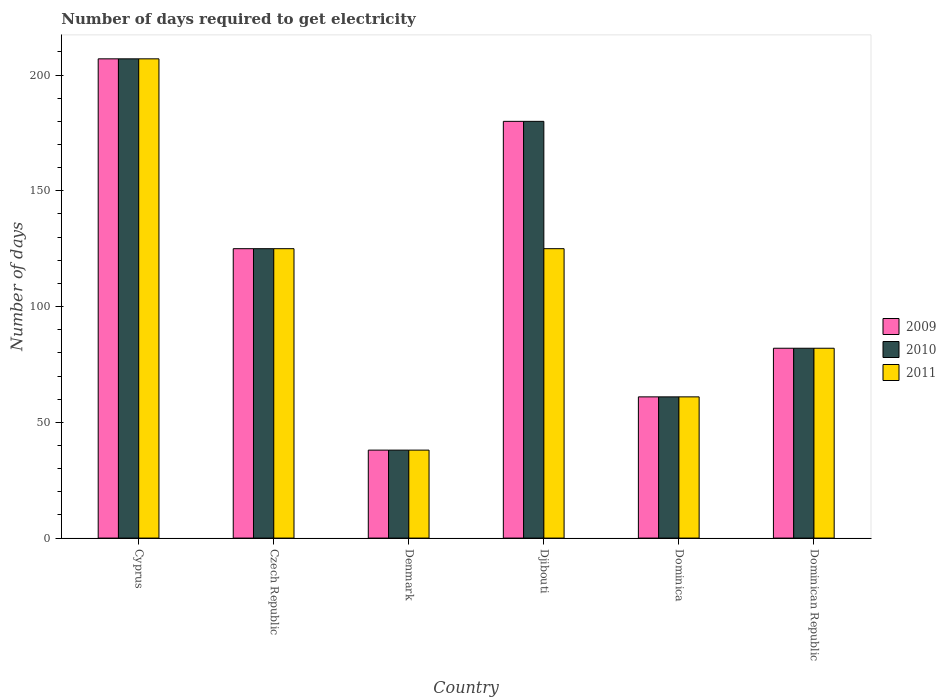How many different coloured bars are there?
Your response must be concise. 3. How many bars are there on the 2nd tick from the left?
Ensure brevity in your answer.  3. How many bars are there on the 4th tick from the right?
Keep it short and to the point. 3. What is the label of the 1st group of bars from the left?
Provide a succinct answer. Cyprus. What is the number of days required to get electricity in in 2011 in Czech Republic?
Keep it short and to the point. 125. Across all countries, what is the maximum number of days required to get electricity in in 2010?
Your response must be concise. 207. Across all countries, what is the minimum number of days required to get electricity in in 2011?
Your answer should be very brief. 38. In which country was the number of days required to get electricity in in 2010 maximum?
Your answer should be compact. Cyprus. In which country was the number of days required to get electricity in in 2010 minimum?
Offer a terse response. Denmark. What is the total number of days required to get electricity in in 2009 in the graph?
Your answer should be compact. 693. What is the difference between the number of days required to get electricity in in 2010 in Cyprus and the number of days required to get electricity in in 2011 in Dominican Republic?
Offer a terse response. 125. What is the average number of days required to get electricity in in 2011 per country?
Your answer should be compact. 106.33. What is the ratio of the number of days required to get electricity in in 2010 in Czech Republic to that in Dominica?
Offer a terse response. 2.05. Is the number of days required to get electricity in in 2010 in Czech Republic less than that in Dominican Republic?
Offer a terse response. No. What is the difference between the highest and the second highest number of days required to get electricity in in 2011?
Your response must be concise. -82. What is the difference between the highest and the lowest number of days required to get electricity in in 2009?
Keep it short and to the point. 169. In how many countries, is the number of days required to get electricity in in 2010 greater than the average number of days required to get electricity in in 2010 taken over all countries?
Your response must be concise. 3. What does the 2nd bar from the left in Denmark represents?
Provide a short and direct response. 2010. What does the 2nd bar from the right in Djibouti represents?
Your answer should be compact. 2010. How many bars are there?
Provide a succinct answer. 18. How many countries are there in the graph?
Offer a terse response. 6. What is the difference between two consecutive major ticks on the Y-axis?
Your answer should be very brief. 50. Does the graph contain grids?
Make the answer very short. No. Where does the legend appear in the graph?
Give a very brief answer. Center right. What is the title of the graph?
Provide a short and direct response. Number of days required to get electricity. What is the label or title of the X-axis?
Offer a very short reply. Country. What is the label or title of the Y-axis?
Provide a succinct answer. Number of days. What is the Number of days in 2009 in Cyprus?
Keep it short and to the point. 207. What is the Number of days of 2010 in Cyprus?
Ensure brevity in your answer.  207. What is the Number of days of 2011 in Cyprus?
Offer a very short reply. 207. What is the Number of days in 2009 in Czech Republic?
Make the answer very short. 125. What is the Number of days in 2010 in Czech Republic?
Make the answer very short. 125. What is the Number of days of 2011 in Czech Republic?
Your response must be concise. 125. What is the Number of days of 2009 in Denmark?
Your response must be concise. 38. What is the Number of days in 2009 in Djibouti?
Offer a very short reply. 180. What is the Number of days of 2010 in Djibouti?
Your answer should be compact. 180. What is the Number of days in 2011 in Djibouti?
Offer a terse response. 125. What is the Number of days in 2009 in Dominica?
Offer a terse response. 61. What is the Number of days of 2010 in Dominica?
Your answer should be very brief. 61. What is the Number of days in 2011 in Dominica?
Provide a short and direct response. 61. Across all countries, what is the maximum Number of days of 2009?
Make the answer very short. 207. Across all countries, what is the maximum Number of days in 2010?
Your response must be concise. 207. Across all countries, what is the maximum Number of days in 2011?
Give a very brief answer. 207. Across all countries, what is the minimum Number of days of 2010?
Make the answer very short. 38. Across all countries, what is the minimum Number of days in 2011?
Ensure brevity in your answer.  38. What is the total Number of days in 2009 in the graph?
Your response must be concise. 693. What is the total Number of days in 2010 in the graph?
Ensure brevity in your answer.  693. What is the total Number of days in 2011 in the graph?
Your response must be concise. 638. What is the difference between the Number of days of 2010 in Cyprus and that in Czech Republic?
Make the answer very short. 82. What is the difference between the Number of days of 2011 in Cyprus and that in Czech Republic?
Offer a very short reply. 82. What is the difference between the Number of days of 2009 in Cyprus and that in Denmark?
Make the answer very short. 169. What is the difference between the Number of days in 2010 in Cyprus and that in Denmark?
Keep it short and to the point. 169. What is the difference between the Number of days in 2011 in Cyprus and that in Denmark?
Make the answer very short. 169. What is the difference between the Number of days of 2009 in Cyprus and that in Dominica?
Provide a short and direct response. 146. What is the difference between the Number of days of 2010 in Cyprus and that in Dominica?
Offer a terse response. 146. What is the difference between the Number of days of 2011 in Cyprus and that in Dominica?
Your answer should be very brief. 146. What is the difference between the Number of days in 2009 in Cyprus and that in Dominican Republic?
Ensure brevity in your answer.  125. What is the difference between the Number of days of 2010 in Cyprus and that in Dominican Republic?
Provide a succinct answer. 125. What is the difference between the Number of days of 2011 in Cyprus and that in Dominican Republic?
Ensure brevity in your answer.  125. What is the difference between the Number of days in 2010 in Czech Republic and that in Denmark?
Keep it short and to the point. 87. What is the difference between the Number of days in 2009 in Czech Republic and that in Djibouti?
Offer a terse response. -55. What is the difference between the Number of days of 2010 in Czech Republic and that in Djibouti?
Offer a terse response. -55. What is the difference between the Number of days of 2010 in Czech Republic and that in Dominica?
Make the answer very short. 64. What is the difference between the Number of days in 2009 in Czech Republic and that in Dominican Republic?
Provide a succinct answer. 43. What is the difference between the Number of days of 2010 in Czech Republic and that in Dominican Republic?
Ensure brevity in your answer.  43. What is the difference between the Number of days of 2011 in Czech Republic and that in Dominican Republic?
Make the answer very short. 43. What is the difference between the Number of days in 2009 in Denmark and that in Djibouti?
Make the answer very short. -142. What is the difference between the Number of days of 2010 in Denmark and that in Djibouti?
Offer a very short reply. -142. What is the difference between the Number of days in 2011 in Denmark and that in Djibouti?
Keep it short and to the point. -87. What is the difference between the Number of days of 2009 in Denmark and that in Dominica?
Offer a terse response. -23. What is the difference between the Number of days of 2011 in Denmark and that in Dominica?
Provide a succinct answer. -23. What is the difference between the Number of days of 2009 in Denmark and that in Dominican Republic?
Your response must be concise. -44. What is the difference between the Number of days of 2010 in Denmark and that in Dominican Republic?
Offer a very short reply. -44. What is the difference between the Number of days of 2011 in Denmark and that in Dominican Republic?
Offer a terse response. -44. What is the difference between the Number of days in 2009 in Djibouti and that in Dominica?
Provide a short and direct response. 119. What is the difference between the Number of days of 2010 in Djibouti and that in Dominica?
Provide a short and direct response. 119. What is the difference between the Number of days of 2011 in Djibouti and that in Dominica?
Your answer should be very brief. 64. What is the difference between the Number of days in 2009 in Djibouti and that in Dominican Republic?
Your answer should be compact. 98. What is the difference between the Number of days in 2010 in Djibouti and that in Dominican Republic?
Give a very brief answer. 98. What is the difference between the Number of days in 2010 in Dominica and that in Dominican Republic?
Ensure brevity in your answer.  -21. What is the difference between the Number of days in 2011 in Dominica and that in Dominican Republic?
Your response must be concise. -21. What is the difference between the Number of days of 2009 in Cyprus and the Number of days of 2010 in Denmark?
Ensure brevity in your answer.  169. What is the difference between the Number of days of 2009 in Cyprus and the Number of days of 2011 in Denmark?
Keep it short and to the point. 169. What is the difference between the Number of days of 2010 in Cyprus and the Number of days of 2011 in Denmark?
Ensure brevity in your answer.  169. What is the difference between the Number of days of 2009 in Cyprus and the Number of days of 2010 in Djibouti?
Make the answer very short. 27. What is the difference between the Number of days of 2009 in Cyprus and the Number of days of 2011 in Djibouti?
Provide a short and direct response. 82. What is the difference between the Number of days of 2010 in Cyprus and the Number of days of 2011 in Djibouti?
Ensure brevity in your answer.  82. What is the difference between the Number of days in 2009 in Cyprus and the Number of days in 2010 in Dominica?
Provide a succinct answer. 146. What is the difference between the Number of days in 2009 in Cyprus and the Number of days in 2011 in Dominica?
Offer a very short reply. 146. What is the difference between the Number of days in 2010 in Cyprus and the Number of days in 2011 in Dominica?
Ensure brevity in your answer.  146. What is the difference between the Number of days in 2009 in Cyprus and the Number of days in 2010 in Dominican Republic?
Ensure brevity in your answer.  125. What is the difference between the Number of days in 2009 in Cyprus and the Number of days in 2011 in Dominican Republic?
Keep it short and to the point. 125. What is the difference between the Number of days of 2010 in Cyprus and the Number of days of 2011 in Dominican Republic?
Make the answer very short. 125. What is the difference between the Number of days in 2009 in Czech Republic and the Number of days in 2011 in Denmark?
Provide a succinct answer. 87. What is the difference between the Number of days of 2010 in Czech Republic and the Number of days of 2011 in Denmark?
Provide a short and direct response. 87. What is the difference between the Number of days of 2009 in Czech Republic and the Number of days of 2010 in Djibouti?
Ensure brevity in your answer.  -55. What is the difference between the Number of days in 2009 in Czech Republic and the Number of days in 2010 in Dominica?
Provide a short and direct response. 64. What is the difference between the Number of days in 2010 in Czech Republic and the Number of days in 2011 in Dominica?
Offer a terse response. 64. What is the difference between the Number of days of 2009 in Czech Republic and the Number of days of 2010 in Dominican Republic?
Offer a terse response. 43. What is the difference between the Number of days in 2009 in Czech Republic and the Number of days in 2011 in Dominican Republic?
Keep it short and to the point. 43. What is the difference between the Number of days in 2010 in Czech Republic and the Number of days in 2011 in Dominican Republic?
Offer a terse response. 43. What is the difference between the Number of days in 2009 in Denmark and the Number of days in 2010 in Djibouti?
Offer a terse response. -142. What is the difference between the Number of days of 2009 in Denmark and the Number of days of 2011 in Djibouti?
Keep it short and to the point. -87. What is the difference between the Number of days in 2010 in Denmark and the Number of days in 2011 in Djibouti?
Offer a very short reply. -87. What is the difference between the Number of days of 2009 in Denmark and the Number of days of 2010 in Dominican Republic?
Ensure brevity in your answer.  -44. What is the difference between the Number of days of 2009 in Denmark and the Number of days of 2011 in Dominican Republic?
Your response must be concise. -44. What is the difference between the Number of days in 2010 in Denmark and the Number of days in 2011 in Dominican Republic?
Ensure brevity in your answer.  -44. What is the difference between the Number of days of 2009 in Djibouti and the Number of days of 2010 in Dominica?
Give a very brief answer. 119. What is the difference between the Number of days in 2009 in Djibouti and the Number of days in 2011 in Dominica?
Your answer should be compact. 119. What is the difference between the Number of days in 2010 in Djibouti and the Number of days in 2011 in Dominica?
Give a very brief answer. 119. What is the difference between the Number of days in 2009 in Djibouti and the Number of days in 2010 in Dominican Republic?
Give a very brief answer. 98. What is the difference between the Number of days in 2009 in Dominica and the Number of days in 2010 in Dominican Republic?
Keep it short and to the point. -21. What is the difference between the Number of days of 2010 in Dominica and the Number of days of 2011 in Dominican Republic?
Provide a short and direct response. -21. What is the average Number of days of 2009 per country?
Keep it short and to the point. 115.5. What is the average Number of days in 2010 per country?
Offer a very short reply. 115.5. What is the average Number of days in 2011 per country?
Offer a very short reply. 106.33. What is the difference between the Number of days of 2009 and Number of days of 2010 in Czech Republic?
Offer a terse response. 0. What is the difference between the Number of days in 2009 and Number of days in 2011 in Denmark?
Your response must be concise. 0. What is the difference between the Number of days in 2010 and Number of days in 2011 in Denmark?
Offer a very short reply. 0. What is the difference between the Number of days of 2009 and Number of days of 2011 in Dominica?
Keep it short and to the point. 0. What is the difference between the Number of days of 2010 and Number of days of 2011 in Dominica?
Your answer should be very brief. 0. What is the difference between the Number of days in 2009 and Number of days in 2010 in Dominican Republic?
Keep it short and to the point. 0. What is the ratio of the Number of days in 2009 in Cyprus to that in Czech Republic?
Offer a terse response. 1.66. What is the ratio of the Number of days in 2010 in Cyprus to that in Czech Republic?
Offer a very short reply. 1.66. What is the ratio of the Number of days in 2011 in Cyprus to that in Czech Republic?
Give a very brief answer. 1.66. What is the ratio of the Number of days in 2009 in Cyprus to that in Denmark?
Provide a short and direct response. 5.45. What is the ratio of the Number of days in 2010 in Cyprus to that in Denmark?
Your answer should be very brief. 5.45. What is the ratio of the Number of days in 2011 in Cyprus to that in Denmark?
Your response must be concise. 5.45. What is the ratio of the Number of days in 2009 in Cyprus to that in Djibouti?
Your answer should be compact. 1.15. What is the ratio of the Number of days in 2010 in Cyprus to that in Djibouti?
Provide a succinct answer. 1.15. What is the ratio of the Number of days in 2011 in Cyprus to that in Djibouti?
Give a very brief answer. 1.66. What is the ratio of the Number of days in 2009 in Cyprus to that in Dominica?
Ensure brevity in your answer.  3.39. What is the ratio of the Number of days of 2010 in Cyprus to that in Dominica?
Provide a succinct answer. 3.39. What is the ratio of the Number of days of 2011 in Cyprus to that in Dominica?
Offer a terse response. 3.39. What is the ratio of the Number of days in 2009 in Cyprus to that in Dominican Republic?
Offer a very short reply. 2.52. What is the ratio of the Number of days in 2010 in Cyprus to that in Dominican Republic?
Keep it short and to the point. 2.52. What is the ratio of the Number of days in 2011 in Cyprus to that in Dominican Republic?
Ensure brevity in your answer.  2.52. What is the ratio of the Number of days of 2009 in Czech Republic to that in Denmark?
Your answer should be very brief. 3.29. What is the ratio of the Number of days in 2010 in Czech Republic to that in Denmark?
Keep it short and to the point. 3.29. What is the ratio of the Number of days in 2011 in Czech Republic to that in Denmark?
Ensure brevity in your answer.  3.29. What is the ratio of the Number of days in 2009 in Czech Republic to that in Djibouti?
Provide a succinct answer. 0.69. What is the ratio of the Number of days in 2010 in Czech Republic to that in Djibouti?
Keep it short and to the point. 0.69. What is the ratio of the Number of days in 2009 in Czech Republic to that in Dominica?
Provide a succinct answer. 2.05. What is the ratio of the Number of days in 2010 in Czech Republic to that in Dominica?
Offer a very short reply. 2.05. What is the ratio of the Number of days of 2011 in Czech Republic to that in Dominica?
Provide a short and direct response. 2.05. What is the ratio of the Number of days of 2009 in Czech Republic to that in Dominican Republic?
Ensure brevity in your answer.  1.52. What is the ratio of the Number of days in 2010 in Czech Republic to that in Dominican Republic?
Give a very brief answer. 1.52. What is the ratio of the Number of days of 2011 in Czech Republic to that in Dominican Republic?
Give a very brief answer. 1.52. What is the ratio of the Number of days of 2009 in Denmark to that in Djibouti?
Ensure brevity in your answer.  0.21. What is the ratio of the Number of days in 2010 in Denmark to that in Djibouti?
Provide a short and direct response. 0.21. What is the ratio of the Number of days in 2011 in Denmark to that in Djibouti?
Offer a very short reply. 0.3. What is the ratio of the Number of days of 2009 in Denmark to that in Dominica?
Ensure brevity in your answer.  0.62. What is the ratio of the Number of days of 2010 in Denmark to that in Dominica?
Make the answer very short. 0.62. What is the ratio of the Number of days of 2011 in Denmark to that in Dominica?
Give a very brief answer. 0.62. What is the ratio of the Number of days of 2009 in Denmark to that in Dominican Republic?
Give a very brief answer. 0.46. What is the ratio of the Number of days of 2010 in Denmark to that in Dominican Republic?
Offer a terse response. 0.46. What is the ratio of the Number of days in 2011 in Denmark to that in Dominican Republic?
Your answer should be very brief. 0.46. What is the ratio of the Number of days of 2009 in Djibouti to that in Dominica?
Make the answer very short. 2.95. What is the ratio of the Number of days in 2010 in Djibouti to that in Dominica?
Offer a very short reply. 2.95. What is the ratio of the Number of days in 2011 in Djibouti to that in Dominica?
Offer a terse response. 2.05. What is the ratio of the Number of days of 2009 in Djibouti to that in Dominican Republic?
Ensure brevity in your answer.  2.2. What is the ratio of the Number of days of 2010 in Djibouti to that in Dominican Republic?
Make the answer very short. 2.2. What is the ratio of the Number of days of 2011 in Djibouti to that in Dominican Republic?
Ensure brevity in your answer.  1.52. What is the ratio of the Number of days of 2009 in Dominica to that in Dominican Republic?
Offer a terse response. 0.74. What is the ratio of the Number of days of 2010 in Dominica to that in Dominican Republic?
Your answer should be compact. 0.74. What is the ratio of the Number of days in 2011 in Dominica to that in Dominican Republic?
Your answer should be very brief. 0.74. What is the difference between the highest and the second highest Number of days of 2010?
Your response must be concise. 27. What is the difference between the highest and the second highest Number of days in 2011?
Your answer should be compact. 82. What is the difference between the highest and the lowest Number of days of 2009?
Give a very brief answer. 169. What is the difference between the highest and the lowest Number of days of 2010?
Make the answer very short. 169. What is the difference between the highest and the lowest Number of days of 2011?
Make the answer very short. 169. 